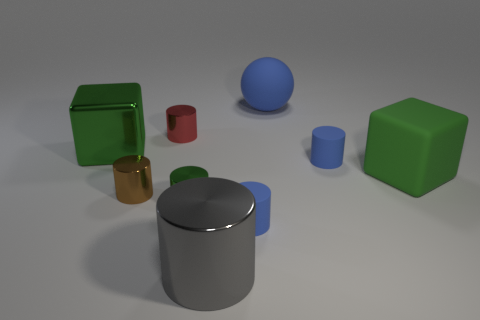Do the large metallic block and the matte ball have the same color?
Provide a short and direct response. No. There is a large object that is in front of the red metallic cylinder and right of the large gray thing; what color is it?
Give a very brief answer. Green. How many things are either objects that are to the left of the big green matte cube or small blue rubber cylinders?
Keep it short and to the point. 8. The other big thing that is the same shape as the large green shiny object is what color?
Your answer should be very brief. Green. There is a tiny red metallic object; does it have the same shape as the green rubber thing that is to the right of the gray shiny thing?
Offer a terse response. No. What number of things are either metal cylinders that are in front of the small green metal object or tiny matte cylinders in front of the small brown shiny cylinder?
Make the answer very short. 2. Is the number of large shiny objects that are right of the small green cylinder less than the number of gray things?
Keep it short and to the point. No. Does the red cylinder have the same material as the block to the left of the small red metallic cylinder?
Your answer should be compact. Yes. What is the material of the large gray thing?
Your answer should be compact. Metal. There is a large object in front of the small shiny cylinder to the left of the red thing that is to the left of the tiny green cylinder; what is it made of?
Offer a very short reply. Metal. 